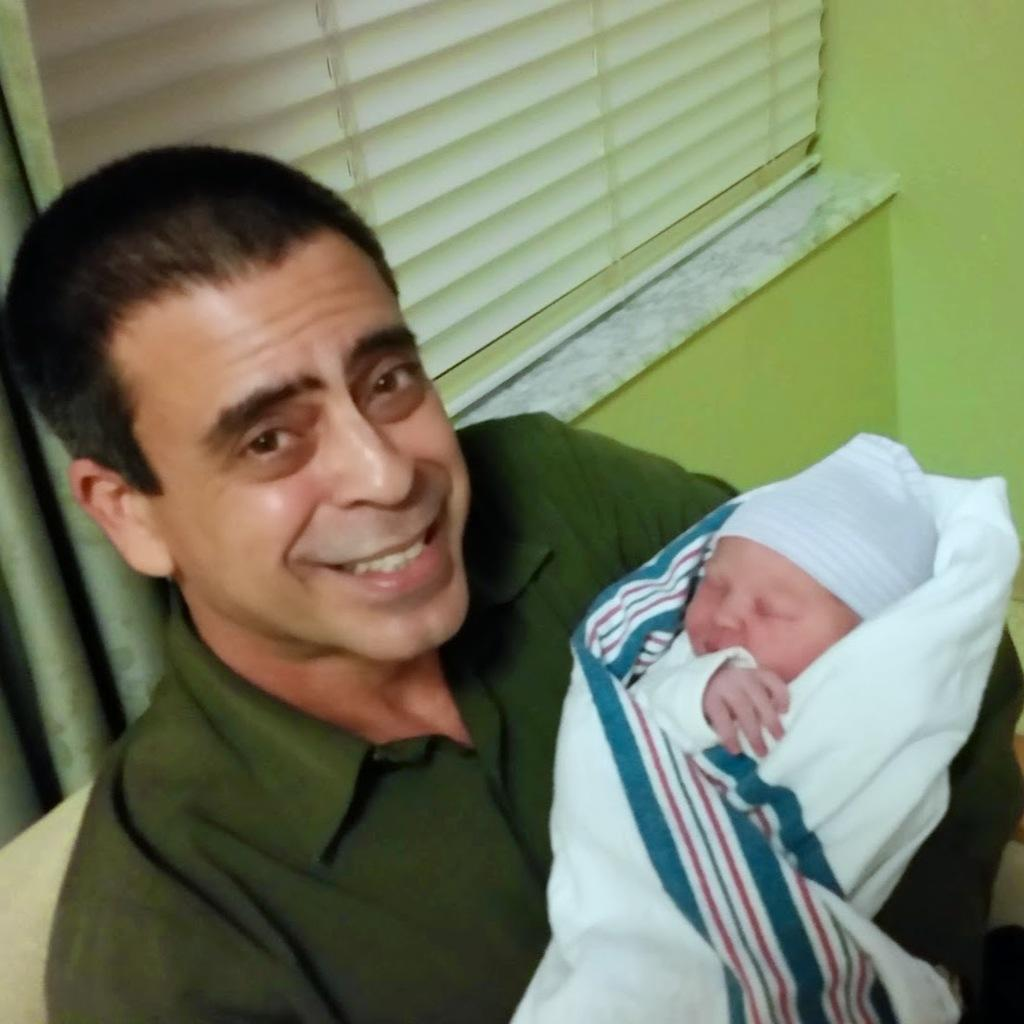What is the person in the image doing? The person is holding a baby in the image. What can be seen in the background of the image? There is a window in the image. Where is the window located? The window is on a wall. What type of territory is being claimed by the baby in the image? There is no territory being claimed in the image; the baby is simply being held by the person. What is the baby crying about in the image? There is no indication that the baby is crying in the image. 